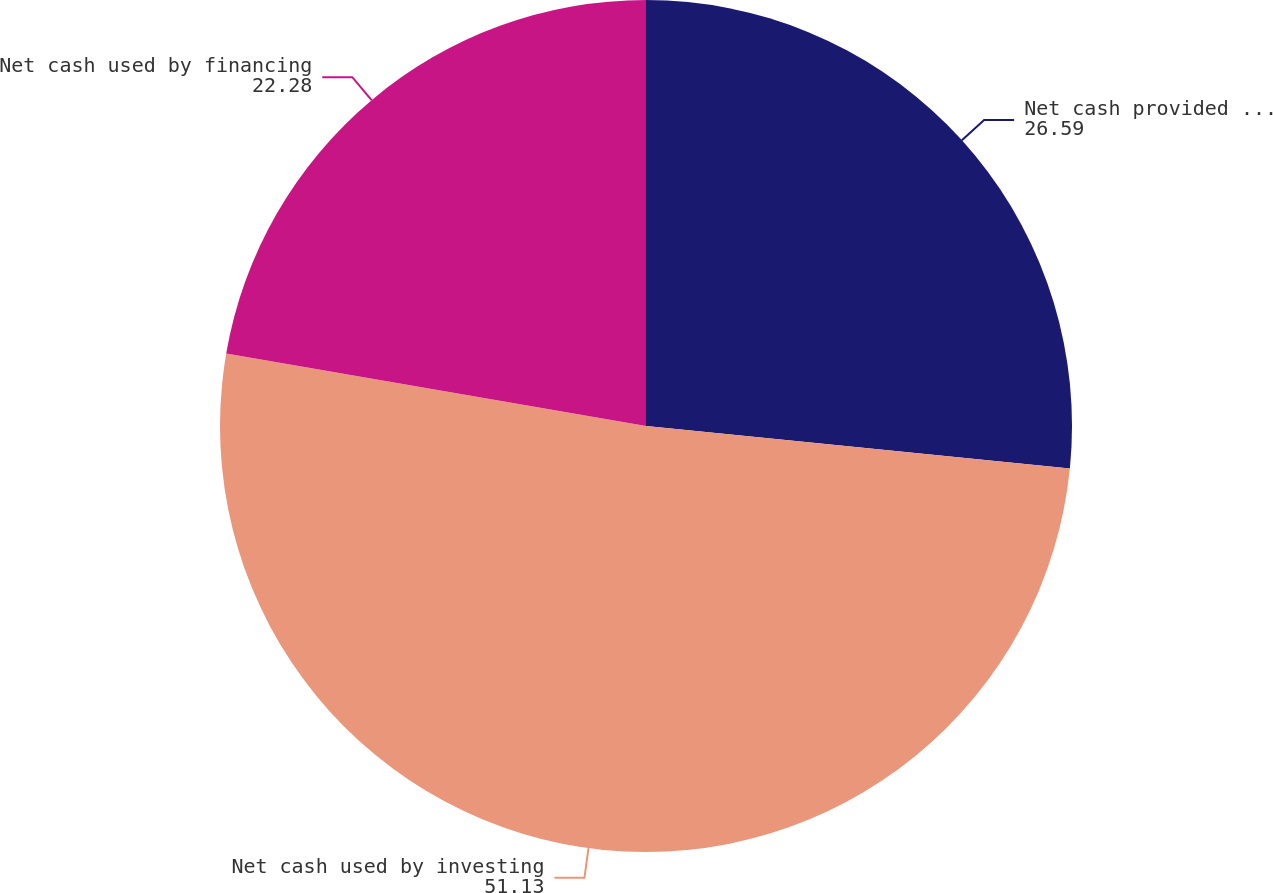<chart> <loc_0><loc_0><loc_500><loc_500><pie_chart><fcel>Net cash provided by operating<fcel>Net cash used by investing<fcel>Net cash used by financing<nl><fcel>26.59%<fcel>51.13%<fcel>22.28%<nl></chart> 